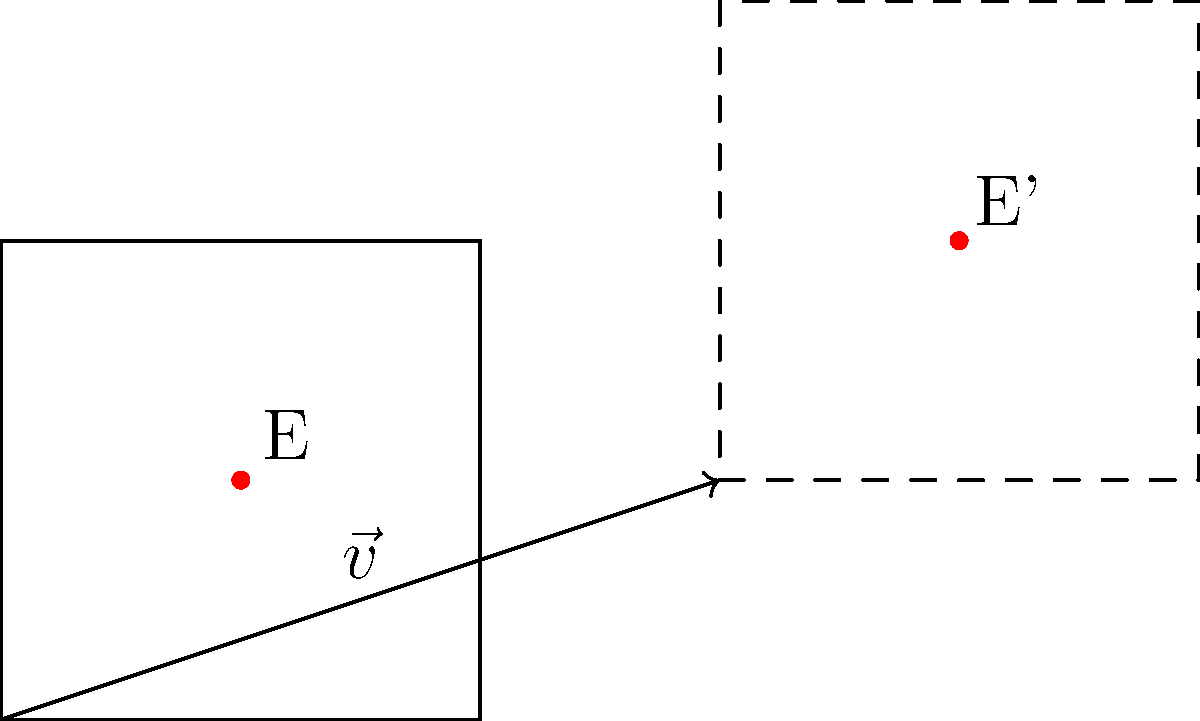Given a square ABCD with side length 2 units and a point E at its center (1,1), translate the entire shape by vector $\vec{v} = (3,1)$. What are the coordinates of point E after the translation? To solve this problem, we'll follow these steps:

1) Understand the initial position:
   The square ABCD has vertices at (0,0), (2,0), (2,2), and (0,2).
   Point E is at the center (1,1).

2) Identify the translation vector:
   $\vec{v} = (3,1)$

3) Apply the translation:
   In a translation, every point of the shape moves by the same vector.
   To find the new position of a point, we add the translation vector to its original coordinates.

4) Calculate the new position of E:
   Original position of E: $(1,1)$
   Translation vector: $(3,1)$
   
   New position = Original position + Translation vector
                = $(1,1) + (3,1)$
                = $(1+3, 1+1)$
                = $(4,2)$

Therefore, after the translation, point E moves to position (4,2).
Answer: $(4,2)$ 